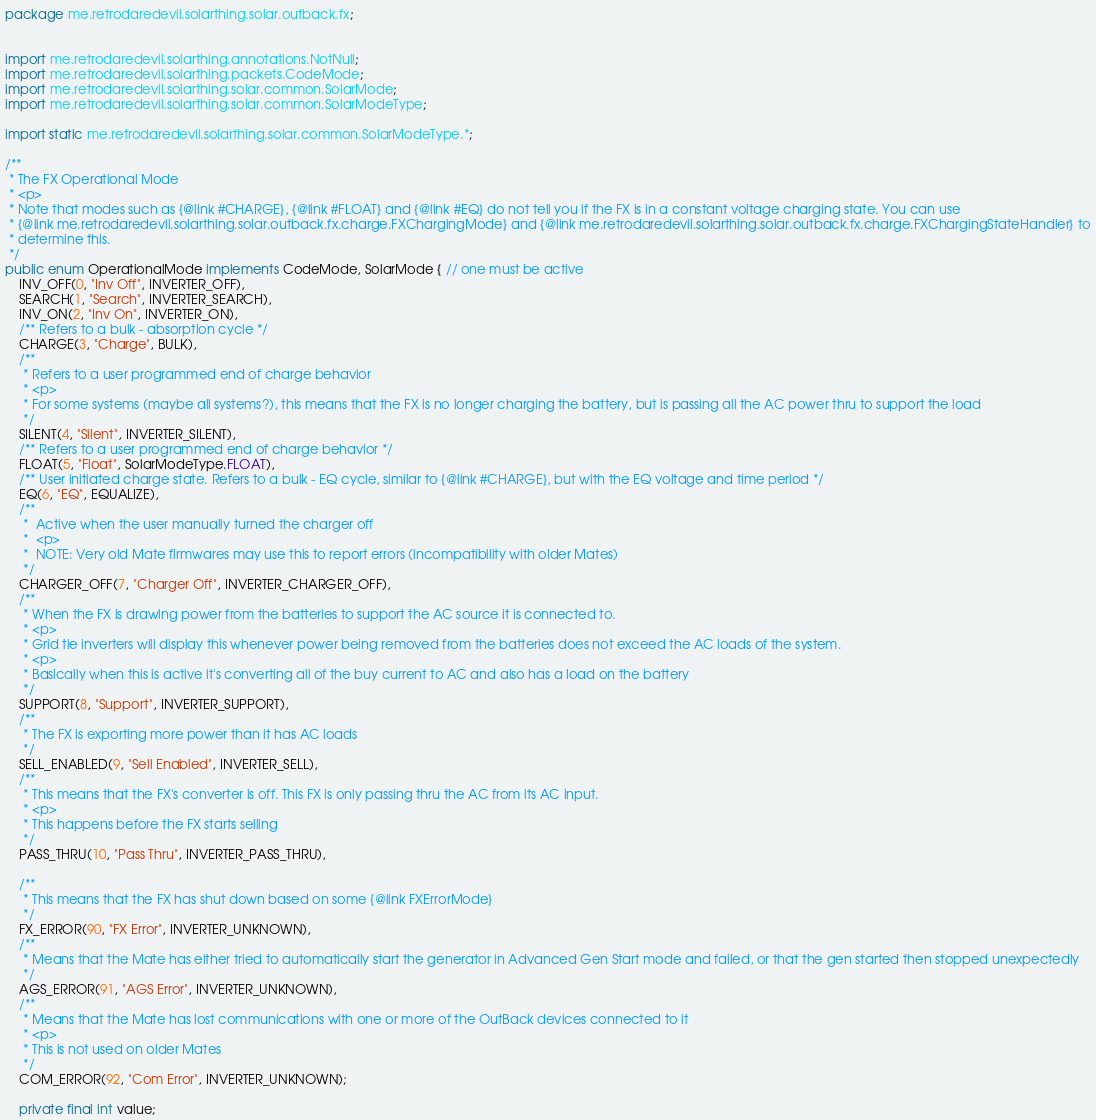<code> <loc_0><loc_0><loc_500><loc_500><_Java_>package me.retrodaredevil.solarthing.solar.outback.fx;


import me.retrodaredevil.solarthing.annotations.NotNull;
import me.retrodaredevil.solarthing.packets.CodeMode;
import me.retrodaredevil.solarthing.solar.common.SolarMode;
import me.retrodaredevil.solarthing.solar.common.SolarModeType;

import static me.retrodaredevil.solarthing.solar.common.SolarModeType.*;

/**
 * The FX Operational Mode
 * <p>
 * Note that modes such as {@link #CHARGE}, {@link #FLOAT} and {@link #EQ} do not tell you if the FX is in a constant voltage charging state. You can use
 * {@link me.retrodaredevil.solarthing.solar.outback.fx.charge.FXChargingMode} and {@link me.retrodaredevil.solarthing.solar.outback.fx.charge.FXChargingStateHandler} to
 * determine this.
 */
public enum OperationalMode implements CodeMode, SolarMode { // one must be active
	INV_OFF(0, "Inv Off", INVERTER_OFF),
	SEARCH(1, "Search", INVERTER_SEARCH),
	INV_ON(2, "Inv On", INVERTER_ON),
	/** Refers to a bulk - absorption cycle */
	CHARGE(3, "Charge", BULK),
	/**
	 * Refers to a user programmed end of charge behavior
	 * <p>
	 * For some systems (maybe all systems?), this means that the FX is no longer charging the battery, but is passing all the AC power thru to support the load
	 */
	SILENT(4, "Silent", INVERTER_SILENT),
	/** Refers to a user programmed end of charge behavior */
	FLOAT(5, "Float", SolarModeType.FLOAT),
	/** User initiated charge state. Refers to a bulk - EQ cycle, similar to {@link #CHARGE}, but with the EQ voltage and time period */
	EQ(6, "EQ", EQUALIZE),
	/**
	 *  Active when the user manually turned the charger off
	 *  <p>
	 *  NOTE: Very old Mate firmwares may use this to report errors (incompatibility with older Mates)
	 */
	CHARGER_OFF(7, "Charger Off", INVERTER_CHARGER_OFF),
	/**
	 * When the FX is drawing power from the batteries to support the AC source it is connected to.
	 * <p>
	 * Grid tie inverters will display this whenever power being removed from the batteries does not exceed the AC loads of the system.
	 * <p>
	 * Basically when this is active it's converting all of the buy current to AC and also has a load on the battery
	 */
	SUPPORT(8, "Support", INVERTER_SUPPORT),
	/**
	 * The FX is exporting more power than it has AC loads
	 */
	SELL_ENABLED(9, "Sell Enabled", INVERTER_SELL),
	/**
	 * This means that the FX's converter is off. This FX is only passing thru the AC from its AC input.
	 * <p>
	 * This happens before the FX starts selling
	 */
	PASS_THRU(10, "Pass Thru", INVERTER_PASS_THRU),

	/**
	 * This means that the FX has shut down based on some {@link FXErrorMode}
	 */
	FX_ERROR(90, "FX Error", INVERTER_UNKNOWN),
	/**
	 * Means that the Mate has either tried to automatically start the generator in Advanced Gen Start mode and failed, or that the gen started then stopped unexpectedly
	 */
	AGS_ERROR(91, "AGS Error", INVERTER_UNKNOWN),
	/**
	 * Means that the Mate has lost communications with one or more of the OutBack devices connected to it
	 * <p>
	 * This is not used on older Mates
	 */
	COM_ERROR(92, "Com Error", INVERTER_UNKNOWN);

	private final int value;</code> 